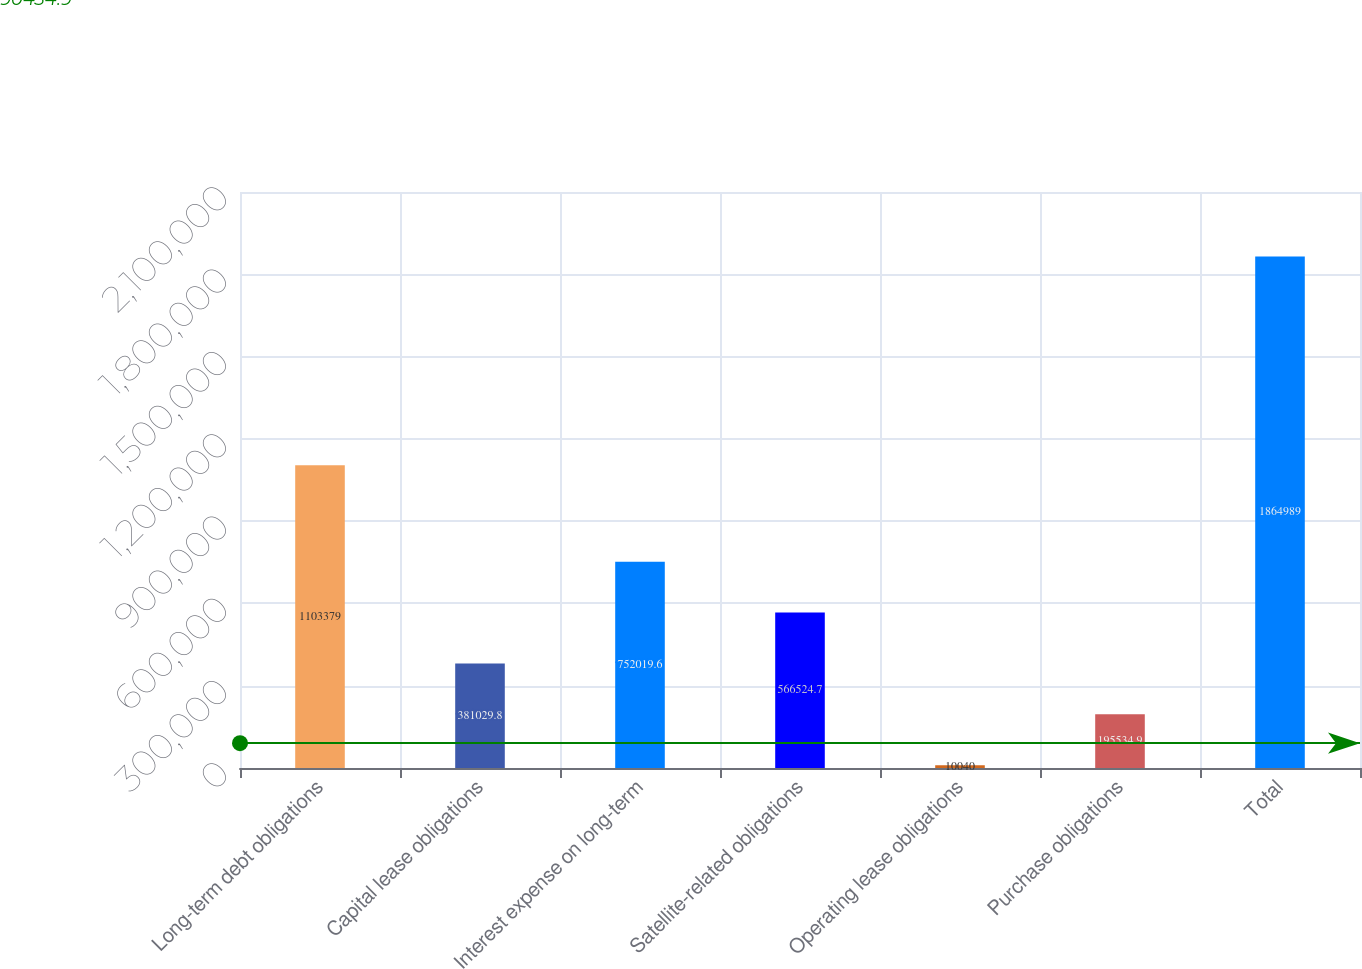Convert chart. <chart><loc_0><loc_0><loc_500><loc_500><bar_chart><fcel>Long-term debt obligations<fcel>Capital lease obligations<fcel>Interest expense on long-term<fcel>Satellite-related obligations<fcel>Operating lease obligations<fcel>Purchase obligations<fcel>Total<nl><fcel>1.10338e+06<fcel>381030<fcel>752020<fcel>566525<fcel>10040<fcel>195535<fcel>1.86499e+06<nl></chart> 